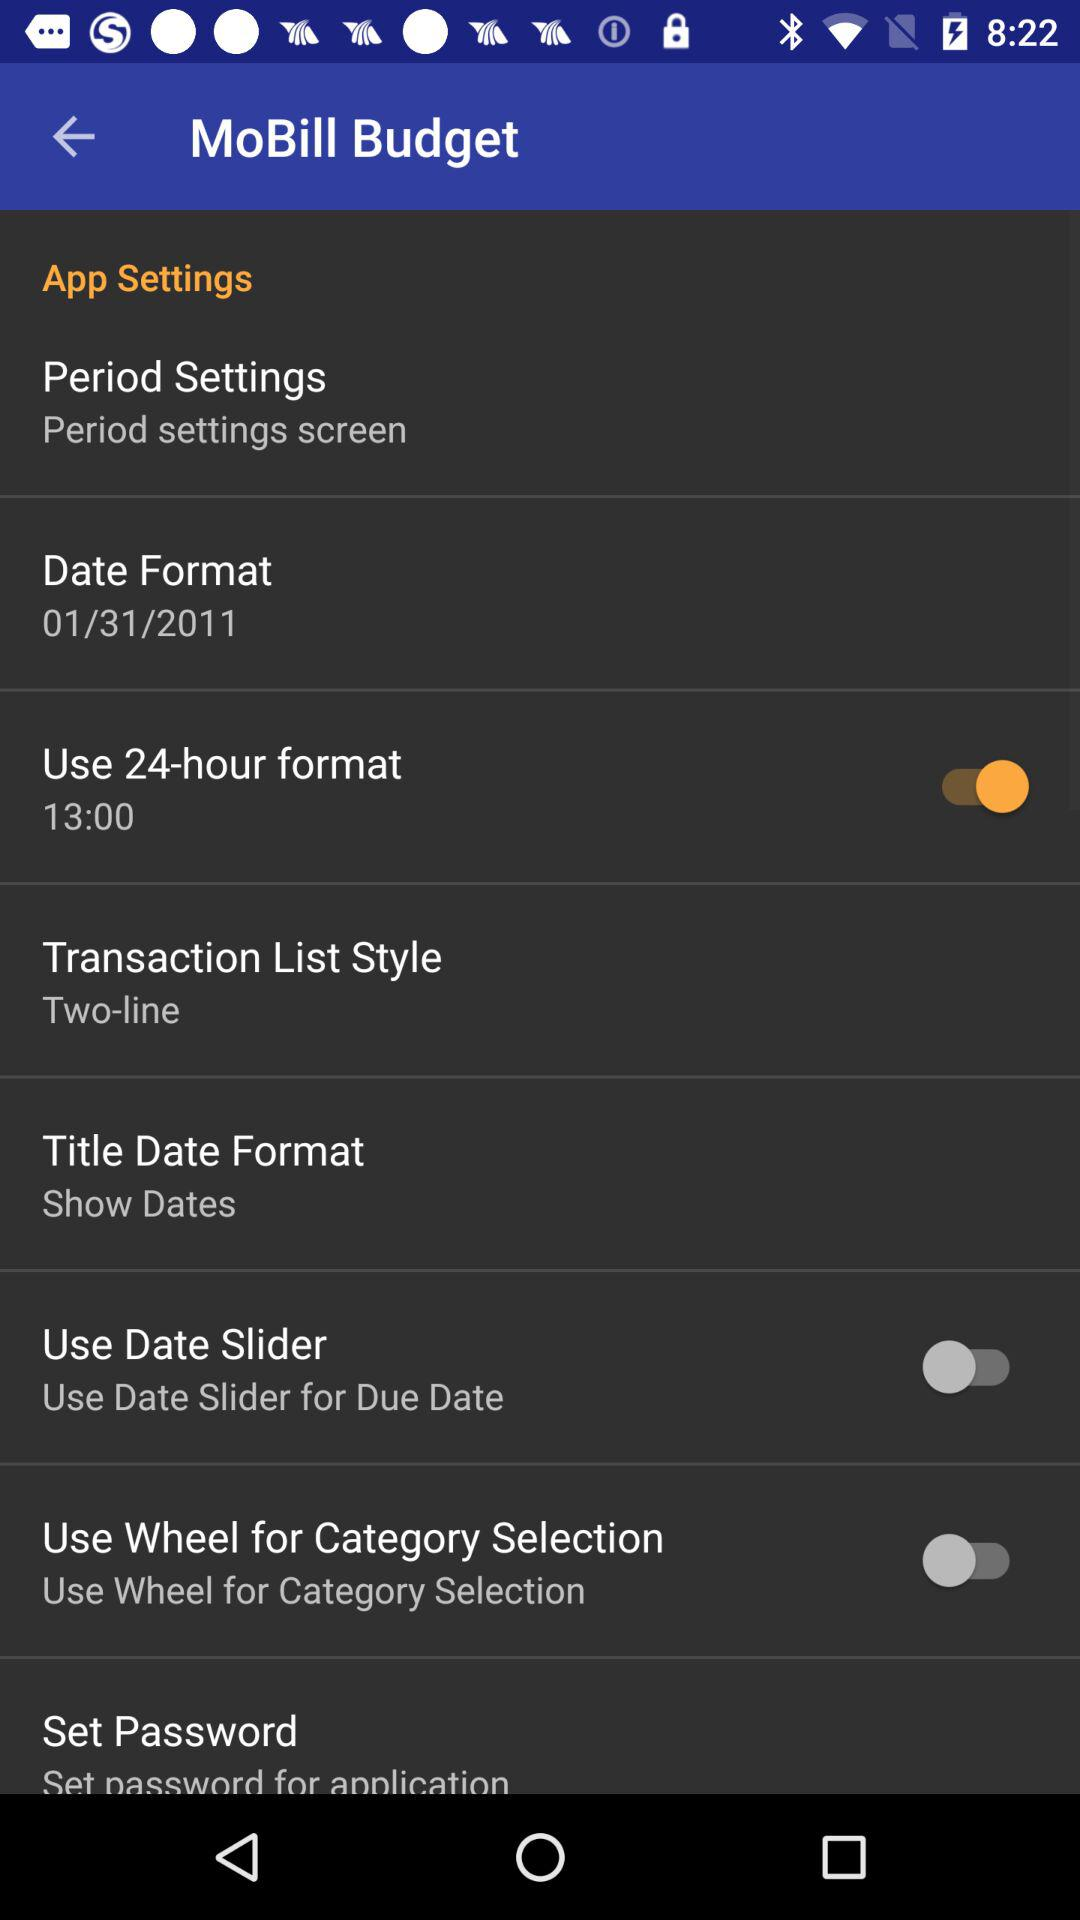What is the status of "Use Wheel for Category Selection"? The status of "Use Wheel for Category Selection" is "off". 